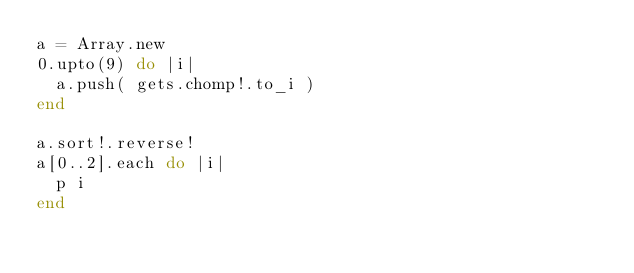<code> <loc_0><loc_0><loc_500><loc_500><_Ruby_>a = Array.new
0.upto(9) do |i|
	a.push( gets.chomp!.to_i )
end

a.sort!.reverse!
a[0..2].each do |i|
	p i
end</code> 